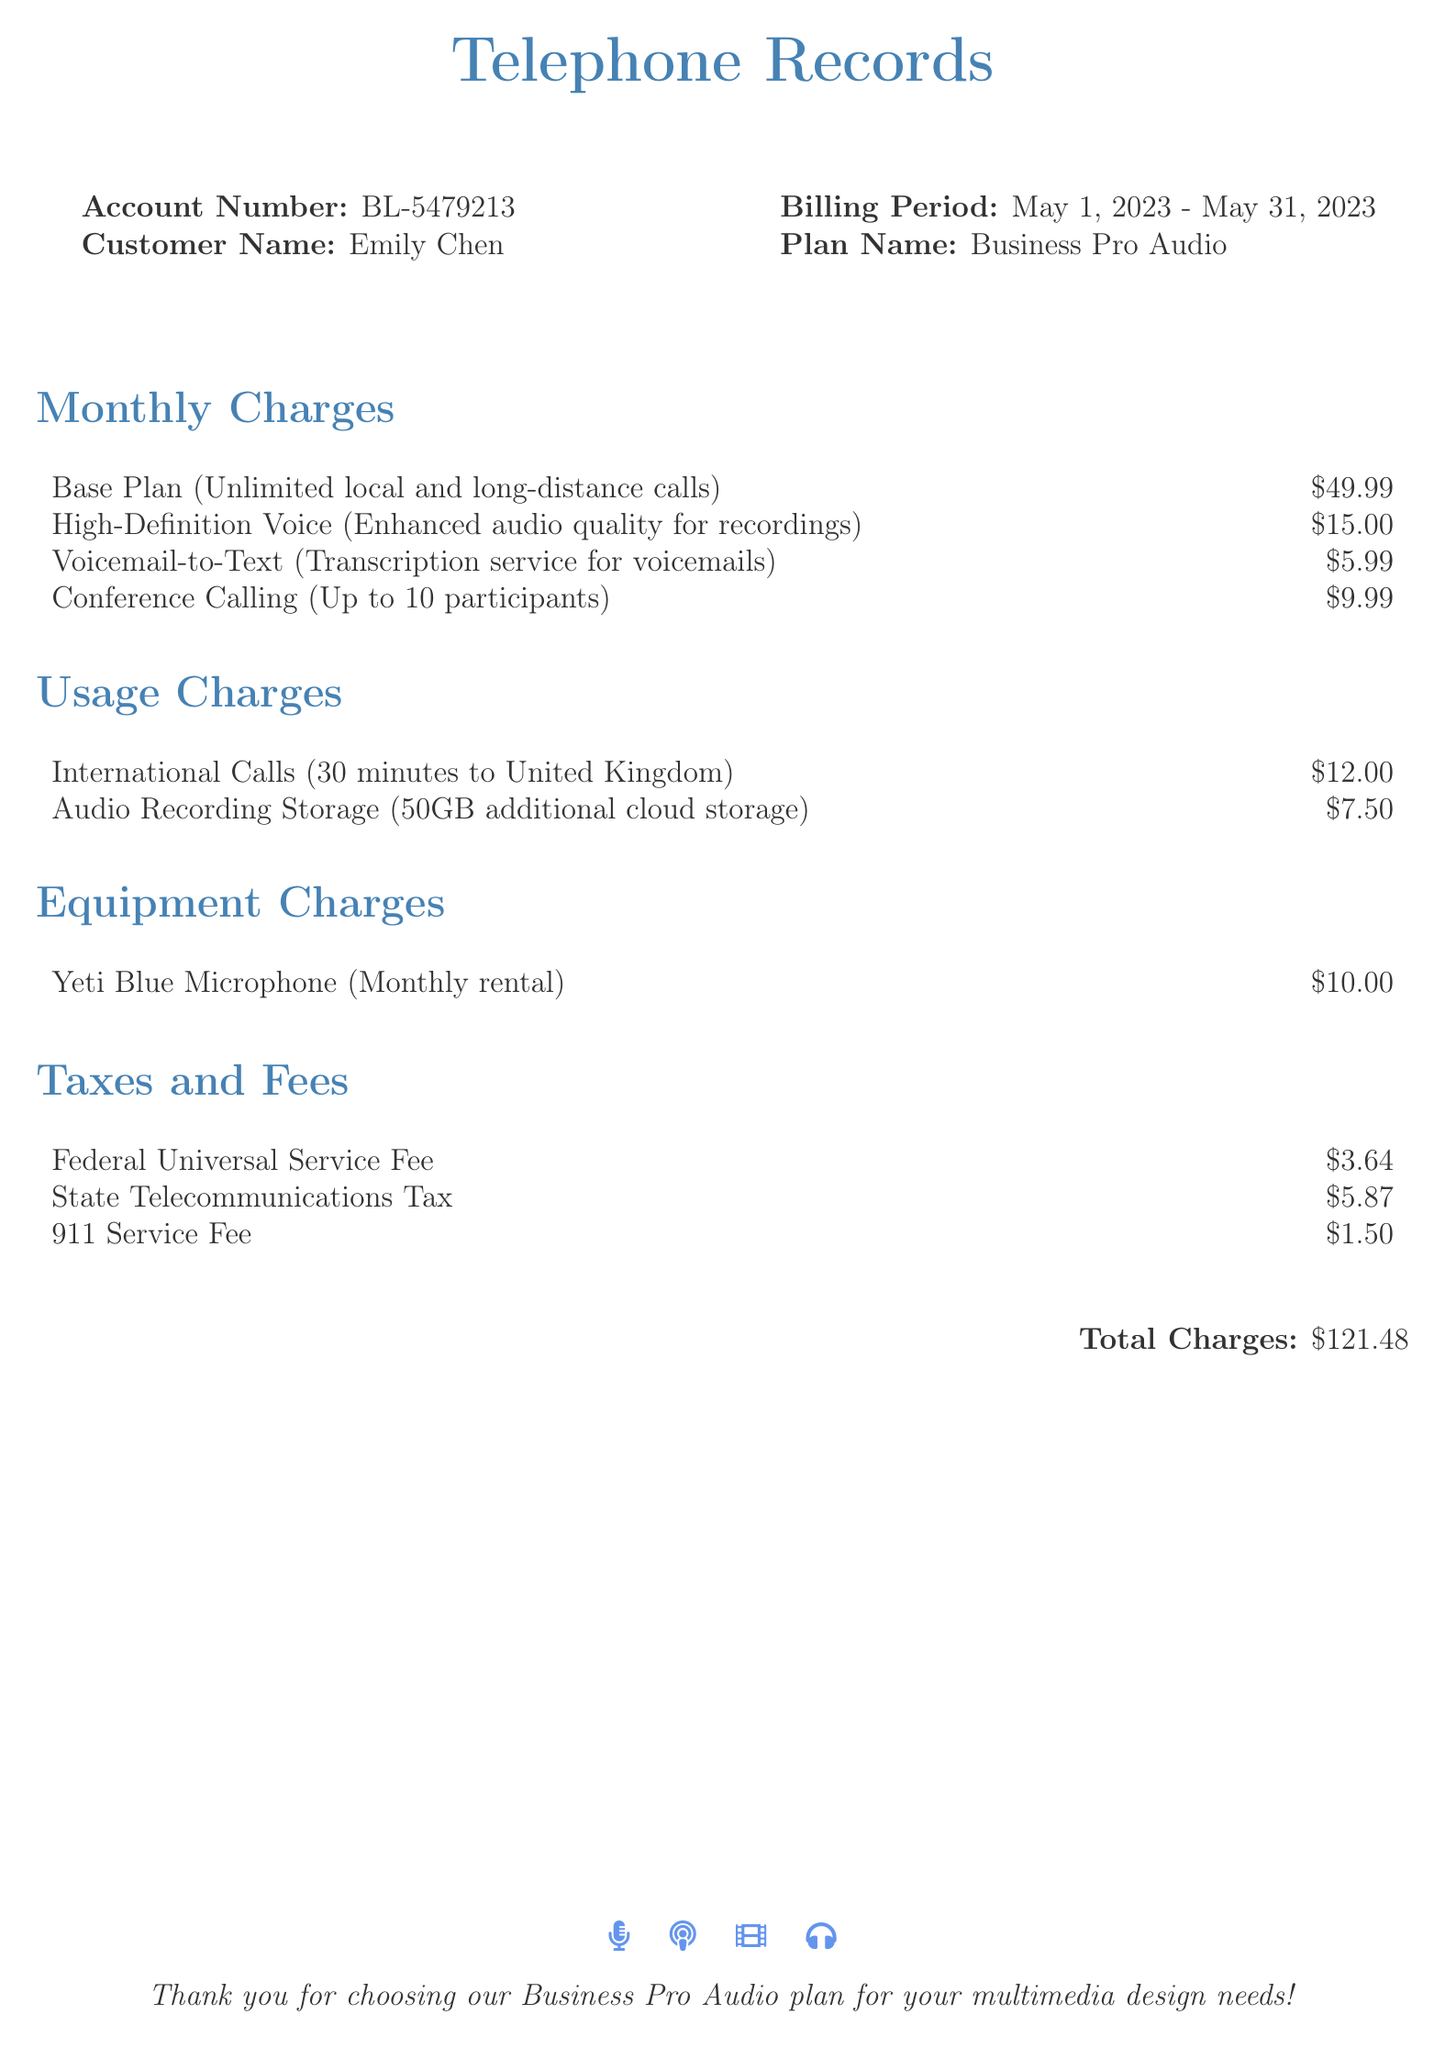What is the account number? The account number is specifically listed in the document under the account section.
Answer: BL-5479213 Who is the customer? The customer's name is mentioned in the document under the customer section.
Answer: Emily Chen What is the billing period? The billing period shows the range of dates covered by this bill.
Answer: May 1, 2023 - May 31, 2023 What is the total charge? The document states the total charge at the bottom, combining all charges and fees.
Answer: $121.48 How much is the rental for the Yeti Blue Microphone? The monthly rental fee for the microphone is itemized in the equipment charges.
Answer: $10.00 What service provides voicemail transcription? The service listed that provides voicemail transcription is highlighted in the monthly charges.
Answer: Voicemail-to-Text How many minutes of international calls were made? The specifics of the international calls are detailed in the usage charges section.
Answer: 30 minutes What is the Federal Universal Service Fee? The Federal Universal Service Fee is included in the taxes and fees section and indicates the amount charged.
Answer: $3.64 What type of plan is this document for? The plan name is specified at the beginning of the document under the plan section.
Answer: Business Pro Audio 